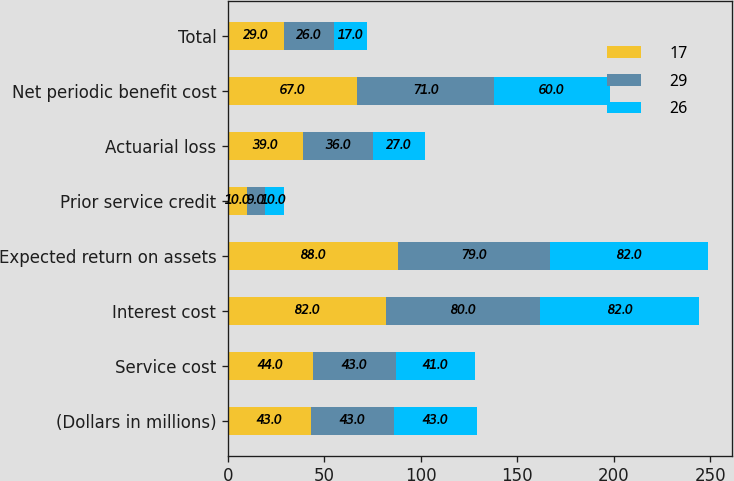<chart> <loc_0><loc_0><loc_500><loc_500><stacked_bar_chart><ecel><fcel>(Dollars in millions)<fcel>Service cost<fcel>Interest cost<fcel>Expected return on assets<fcel>Prior service credit<fcel>Actuarial loss<fcel>Net periodic benefit cost<fcel>Total<nl><fcel>17<fcel>43<fcel>44<fcel>82<fcel>88<fcel>10<fcel>39<fcel>67<fcel>29<nl><fcel>29<fcel>43<fcel>43<fcel>80<fcel>79<fcel>9<fcel>36<fcel>71<fcel>26<nl><fcel>26<fcel>43<fcel>41<fcel>82<fcel>82<fcel>10<fcel>27<fcel>60<fcel>17<nl></chart> 